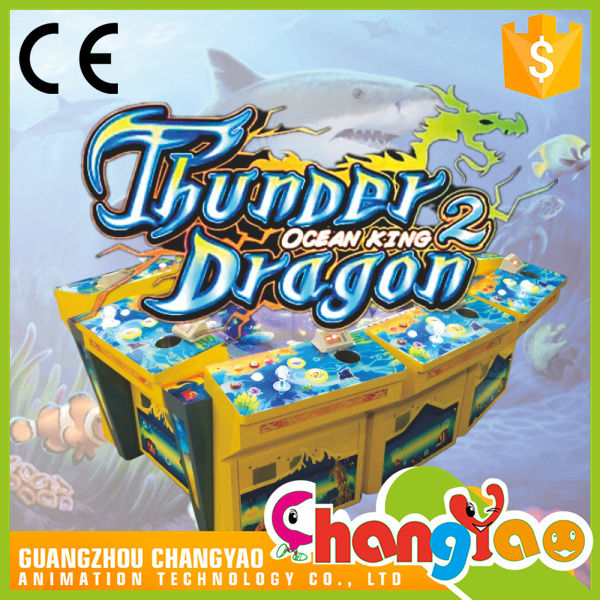What skills might players need to be successful in 'Thunder Dragon 2 Ocean King'? Success in 'Thunder Dragon 2 Ocean King' would likely require a combination of quick reflexes, sharp hand-eye coordination, and strategic planning. Players must be adept at maneuvering the joystick to aim accurately and deploying the fire button to effectively capture or attack the moving targets. Observant players will benefit from noticing patterns in the creatures' movements. Moreover, because it's a multiplayer game, social interaction and the ability to coordinate with fellow players could be a key strategic element, especially in versions of gameplay where cooperation might enhance the chances of defeating more formidable sea creatures or earning higher scores. 